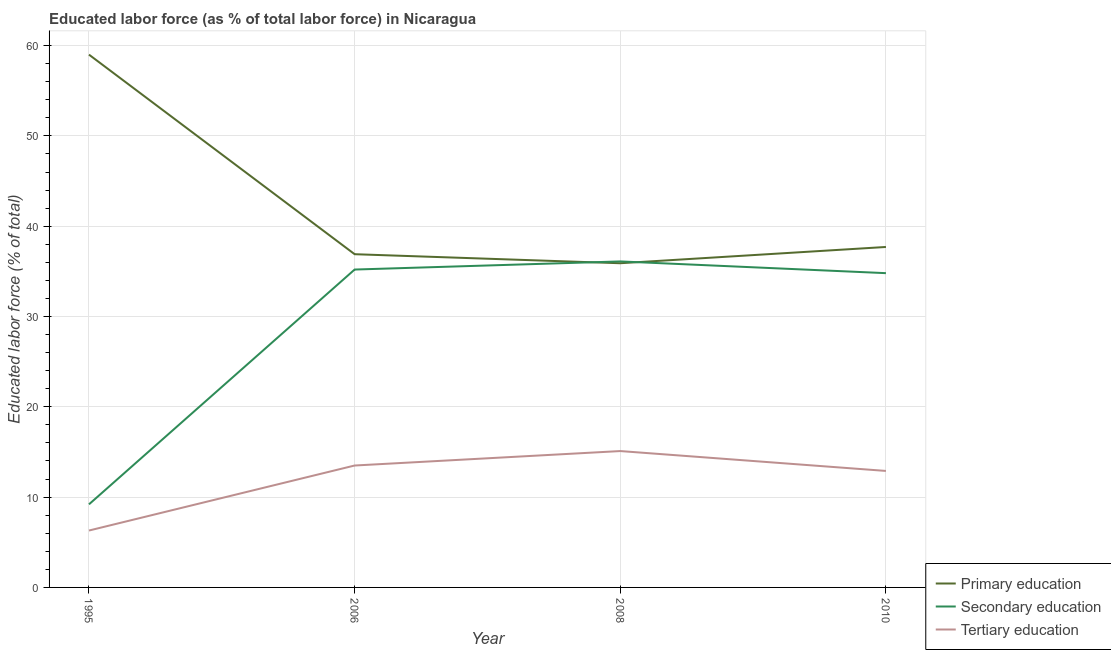Does the line corresponding to percentage of labor force who received secondary education intersect with the line corresponding to percentage of labor force who received primary education?
Provide a short and direct response. Yes. What is the percentage of labor force who received primary education in 2010?
Offer a very short reply. 37.7. Across all years, what is the maximum percentage of labor force who received secondary education?
Ensure brevity in your answer.  36.1. Across all years, what is the minimum percentage of labor force who received primary education?
Keep it short and to the point. 35.9. In which year was the percentage of labor force who received primary education maximum?
Offer a terse response. 1995. In which year was the percentage of labor force who received tertiary education minimum?
Offer a very short reply. 1995. What is the total percentage of labor force who received secondary education in the graph?
Your answer should be compact. 115.3. What is the difference between the percentage of labor force who received tertiary education in 1995 and that in 2006?
Provide a short and direct response. -7.2. What is the difference between the percentage of labor force who received tertiary education in 2010 and the percentage of labor force who received primary education in 2006?
Keep it short and to the point. -24. What is the average percentage of labor force who received tertiary education per year?
Offer a terse response. 11.95. In the year 1995, what is the difference between the percentage of labor force who received primary education and percentage of labor force who received tertiary education?
Provide a short and direct response. 52.7. In how many years, is the percentage of labor force who received secondary education greater than 34 %?
Keep it short and to the point. 3. What is the ratio of the percentage of labor force who received secondary education in 2006 to that in 2008?
Your answer should be very brief. 0.98. Is the percentage of labor force who received tertiary education in 2006 less than that in 2010?
Your answer should be very brief. No. What is the difference between the highest and the second highest percentage of labor force who received tertiary education?
Ensure brevity in your answer.  1.6. What is the difference between the highest and the lowest percentage of labor force who received tertiary education?
Offer a very short reply. 8.8. In how many years, is the percentage of labor force who received secondary education greater than the average percentage of labor force who received secondary education taken over all years?
Make the answer very short. 3. Is the percentage of labor force who received secondary education strictly greater than the percentage of labor force who received primary education over the years?
Ensure brevity in your answer.  No. How many lines are there?
Offer a terse response. 3. Are the values on the major ticks of Y-axis written in scientific E-notation?
Offer a terse response. No. Does the graph contain grids?
Your response must be concise. Yes. How many legend labels are there?
Your answer should be very brief. 3. What is the title of the graph?
Your answer should be compact. Educated labor force (as % of total labor force) in Nicaragua. Does "Ages 0-14" appear as one of the legend labels in the graph?
Offer a terse response. No. What is the label or title of the X-axis?
Offer a very short reply. Year. What is the label or title of the Y-axis?
Your answer should be very brief. Educated labor force (% of total). What is the Educated labor force (% of total) of Secondary education in 1995?
Offer a terse response. 9.2. What is the Educated labor force (% of total) in Tertiary education in 1995?
Give a very brief answer. 6.3. What is the Educated labor force (% of total) in Primary education in 2006?
Offer a terse response. 36.9. What is the Educated labor force (% of total) in Secondary education in 2006?
Offer a terse response. 35.2. What is the Educated labor force (% of total) of Primary education in 2008?
Keep it short and to the point. 35.9. What is the Educated labor force (% of total) of Secondary education in 2008?
Ensure brevity in your answer.  36.1. What is the Educated labor force (% of total) in Tertiary education in 2008?
Provide a succinct answer. 15.1. What is the Educated labor force (% of total) in Primary education in 2010?
Your response must be concise. 37.7. What is the Educated labor force (% of total) in Secondary education in 2010?
Provide a short and direct response. 34.8. What is the Educated labor force (% of total) of Tertiary education in 2010?
Ensure brevity in your answer.  12.9. Across all years, what is the maximum Educated labor force (% of total) of Secondary education?
Your answer should be compact. 36.1. Across all years, what is the maximum Educated labor force (% of total) of Tertiary education?
Provide a succinct answer. 15.1. Across all years, what is the minimum Educated labor force (% of total) in Primary education?
Give a very brief answer. 35.9. Across all years, what is the minimum Educated labor force (% of total) of Secondary education?
Offer a very short reply. 9.2. Across all years, what is the minimum Educated labor force (% of total) of Tertiary education?
Ensure brevity in your answer.  6.3. What is the total Educated labor force (% of total) in Primary education in the graph?
Provide a succinct answer. 169.5. What is the total Educated labor force (% of total) in Secondary education in the graph?
Give a very brief answer. 115.3. What is the total Educated labor force (% of total) of Tertiary education in the graph?
Ensure brevity in your answer.  47.8. What is the difference between the Educated labor force (% of total) of Primary education in 1995 and that in 2006?
Offer a very short reply. 22.1. What is the difference between the Educated labor force (% of total) in Primary education in 1995 and that in 2008?
Give a very brief answer. 23.1. What is the difference between the Educated labor force (% of total) of Secondary education in 1995 and that in 2008?
Give a very brief answer. -26.9. What is the difference between the Educated labor force (% of total) in Primary education in 1995 and that in 2010?
Provide a succinct answer. 21.3. What is the difference between the Educated labor force (% of total) of Secondary education in 1995 and that in 2010?
Your answer should be very brief. -25.6. What is the difference between the Educated labor force (% of total) of Tertiary education in 1995 and that in 2010?
Make the answer very short. -6.6. What is the difference between the Educated labor force (% of total) of Primary education in 2006 and that in 2008?
Offer a terse response. 1. What is the difference between the Educated labor force (% of total) of Secondary education in 2006 and that in 2008?
Ensure brevity in your answer.  -0.9. What is the difference between the Educated labor force (% of total) in Tertiary education in 2006 and that in 2008?
Offer a terse response. -1.6. What is the difference between the Educated labor force (% of total) in Primary education in 2006 and that in 2010?
Offer a very short reply. -0.8. What is the difference between the Educated labor force (% of total) of Secondary education in 2006 and that in 2010?
Ensure brevity in your answer.  0.4. What is the difference between the Educated labor force (% of total) in Secondary education in 2008 and that in 2010?
Your response must be concise. 1.3. What is the difference between the Educated labor force (% of total) of Primary education in 1995 and the Educated labor force (% of total) of Secondary education in 2006?
Give a very brief answer. 23.8. What is the difference between the Educated labor force (% of total) of Primary education in 1995 and the Educated labor force (% of total) of Tertiary education in 2006?
Make the answer very short. 45.5. What is the difference between the Educated labor force (% of total) in Primary education in 1995 and the Educated labor force (% of total) in Secondary education in 2008?
Ensure brevity in your answer.  22.9. What is the difference between the Educated labor force (% of total) in Primary education in 1995 and the Educated labor force (% of total) in Tertiary education in 2008?
Keep it short and to the point. 43.9. What is the difference between the Educated labor force (% of total) in Secondary education in 1995 and the Educated labor force (% of total) in Tertiary education in 2008?
Offer a very short reply. -5.9. What is the difference between the Educated labor force (% of total) in Primary education in 1995 and the Educated labor force (% of total) in Secondary education in 2010?
Make the answer very short. 24.2. What is the difference between the Educated labor force (% of total) of Primary education in 1995 and the Educated labor force (% of total) of Tertiary education in 2010?
Make the answer very short. 46.1. What is the difference between the Educated labor force (% of total) in Secondary education in 1995 and the Educated labor force (% of total) in Tertiary education in 2010?
Keep it short and to the point. -3.7. What is the difference between the Educated labor force (% of total) in Primary education in 2006 and the Educated labor force (% of total) in Secondary education in 2008?
Your response must be concise. 0.8. What is the difference between the Educated labor force (% of total) in Primary education in 2006 and the Educated labor force (% of total) in Tertiary education in 2008?
Provide a succinct answer. 21.8. What is the difference between the Educated labor force (% of total) of Secondary education in 2006 and the Educated labor force (% of total) of Tertiary education in 2008?
Provide a succinct answer. 20.1. What is the difference between the Educated labor force (% of total) in Secondary education in 2006 and the Educated labor force (% of total) in Tertiary education in 2010?
Provide a succinct answer. 22.3. What is the difference between the Educated labor force (% of total) of Secondary education in 2008 and the Educated labor force (% of total) of Tertiary education in 2010?
Ensure brevity in your answer.  23.2. What is the average Educated labor force (% of total) of Primary education per year?
Provide a succinct answer. 42.38. What is the average Educated labor force (% of total) of Secondary education per year?
Provide a short and direct response. 28.82. What is the average Educated labor force (% of total) of Tertiary education per year?
Ensure brevity in your answer.  11.95. In the year 1995, what is the difference between the Educated labor force (% of total) of Primary education and Educated labor force (% of total) of Secondary education?
Give a very brief answer. 49.8. In the year 1995, what is the difference between the Educated labor force (% of total) in Primary education and Educated labor force (% of total) in Tertiary education?
Offer a terse response. 52.7. In the year 1995, what is the difference between the Educated labor force (% of total) of Secondary education and Educated labor force (% of total) of Tertiary education?
Your response must be concise. 2.9. In the year 2006, what is the difference between the Educated labor force (% of total) of Primary education and Educated labor force (% of total) of Tertiary education?
Provide a short and direct response. 23.4. In the year 2006, what is the difference between the Educated labor force (% of total) in Secondary education and Educated labor force (% of total) in Tertiary education?
Your answer should be compact. 21.7. In the year 2008, what is the difference between the Educated labor force (% of total) in Primary education and Educated labor force (% of total) in Tertiary education?
Your answer should be very brief. 20.8. In the year 2008, what is the difference between the Educated labor force (% of total) of Secondary education and Educated labor force (% of total) of Tertiary education?
Make the answer very short. 21. In the year 2010, what is the difference between the Educated labor force (% of total) in Primary education and Educated labor force (% of total) in Tertiary education?
Offer a terse response. 24.8. In the year 2010, what is the difference between the Educated labor force (% of total) of Secondary education and Educated labor force (% of total) of Tertiary education?
Your answer should be compact. 21.9. What is the ratio of the Educated labor force (% of total) in Primary education in 1995 to that in 2006?
Your answer should be very brief. 1.6. What is the ratio of the Educated labor force (% of total) in Secondary education in 1995 to that in 2006?
Provide a short and direct response. 0.26. What is the ratio of the Educated labor force (% of total) in Tertiary education in 1995 to that in 2006?
Give a very brief answer. 0.47. What is the ratio of the Educated labor force (% of total) of Primary education in 1995 to that in 2008?
Provide a succinct answer. 1.64. What is the ratio of the Educated labor force (% of total) in Secondary education in 1995 to that in 2008?
Provide a short and direct response. 0.25. What is the ratio of the Educated labor force (% of total) of Tertiary education in 1995 to that in 2008?
Keep it short and to the point. 0.42. What is the ratio of the Educated labor force (% of total) in Primary education in 1995 to that in 2010?
Provide a succinct answer. 1.56. What is the ratio of the Educated labor force (% of total) in Secondary education in 1995 to that in 2010?
Offer a terse response. 0.26. What is the ratio of the Educated labor force (% of total) in Tertiary education in 1995 to that in 2010?
Your answer should be very brief. 0.49. What is the ratio of the Educated labor force (% of total) of Primary education in 2006 to that in 2008?
Provide a short and direct response. 1.03. What is the ratio of the Educated labor force (% of total) of Secondary education in 2006 to that in 2008?
Make the answer very short. 0.98. What is the ratio of the Educated labor force (% of total) in Tertiary education in 2006 to that in 2008?
Provide a succinct answer. 0.89. What is the ratio of the Educated labor force (% of total) in Primary education in 2006 to that in 2010?
Ensure brevity in your answer.  0.98. What is the ratio of the Educated labor force (% of total) in Secondary education in 2006 to that in 2010?
Provide a succinct answer. 1.01. What is the ratio of the Educated labor force (% of total) of Tertiary education in 2006 to that in 2010?
Provide a short and direct response. 1.05. What is the ratio of the Educated labor force (% of total) of Primary education in 2008 to that in 2010?
Provide a succinct answer. 0.95. What is the ratio of the Educated labor force (% of total) in Secondary education in 2008 to that in 2010?
Your response must be concise. 1.04. What is the ratio of the Educated labor force (% of total) of Tertiary education in 2008 to that in 2010?
Your answer should be very brief. 1.17. What is the difference between the highest and the second highest Educated labor force (% of total) of Primary education?
Ensure brevity in your answer.  21.3. What is the difference between the highest and the lowest Educated labor force (% of total) in Primary education?
Offer a terse response. 23.1. What is the difference between the highest and the lowest Educated labor force (% of total) in Secondary education?
Your response must be concise. 26.9. What is the difference between the highest and the lowest Educated labor force (% of total) in Tertiary education?
Give a very brief answer. 8.8. 